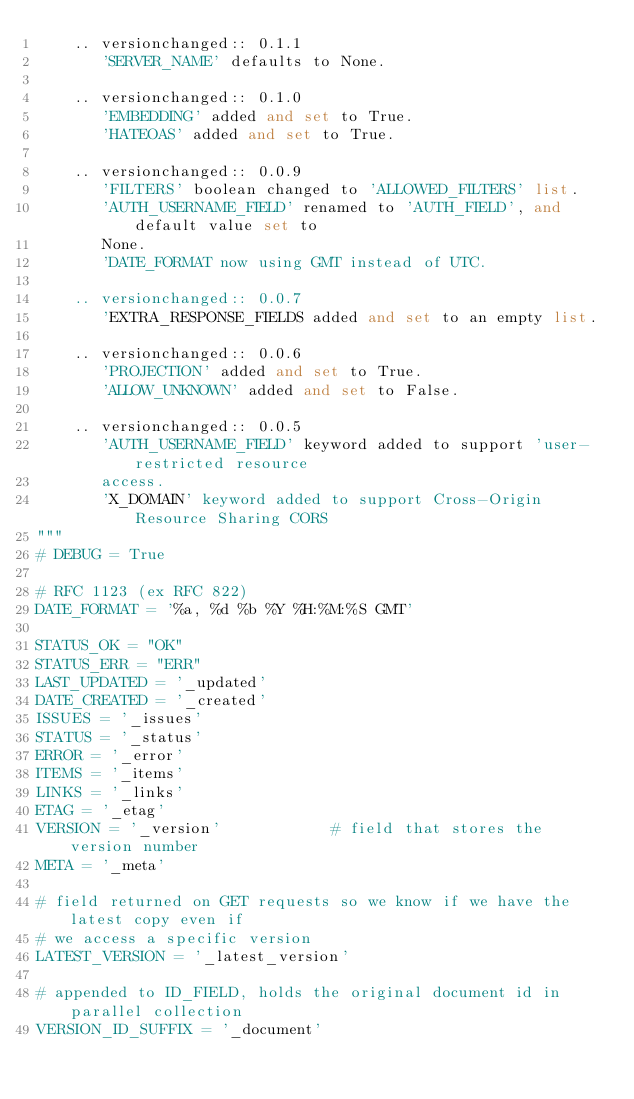Convert code to text. <code><loc_0><loc_0><loc_500><loc_500><_Python_>    .. versionchanged:: 0.1.1
       'SERVER_NAME' defaults to None.

    .. versionchanged:: 0.1.0
       'EMBEDDING' added and set to True.
       'HATEOAS' added and set to True.

    .. versionchanged:: 0.0.9
       'FILTERS' boolean changed to 'ALLOWED_FILTERS' list.
       'AUTH_USERNAME_FIELD' renamed to 'AUTH_FIELD', and default value set to
       None.
       'DATE_FORMAT now using GMT instead of UTC.

    .. versionchanged:: 0.0.7
       'EXTRA_RESPONSE_FIELDS added and set to an empty list.

    .. versionchanged:: 0.0.6
       'PROJECTION' added and set to True.
       'ALLOW_UNKNOWN' added and set to False.

    .. versionchanged:: 0.0.5
       'AUTH_USERNAME_FIELD' keyword added to support 'user-restricted resource
       access.
       'X_DOMAIN' keyword added to support Cross-Origin Resource Sharing CORS
"""
# DEBUG = True

# RFC 1123 (ex RFC 822)
DATE_FORMAT = '%a, %d %b %Y %H:%M:%S GMT'

STATUS_OK = "OK"
STATUS_ERR = "ERR"
LAST_UPDATED = '_updated'
DATE_CREATED = '_created'
ISSUES = '_issues'
STATUS = '_status'
ERROR = '_error'
ITEMS = '_items'
LINKS = '_links'
ETAG = '_etag'
VERSION = '_version'            # field that stores the version number
META = '_meta'

# field returned on GET requests so we know if we have the latest copy even if
# we access a specific version
LATEST_VERSION = '_latest_version'

# appended to ID_FIELD, holds the original document id in parallel collection
VERSION_ID_SUFFIX = '_document'</code> 